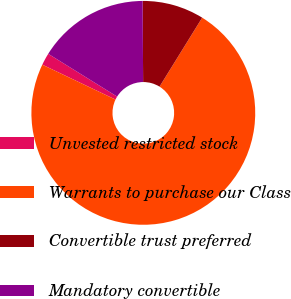Convert chart to OTSL. <chart><loc_0><loc_0><loc_500><loc_500><pie_chart><fcel>Unvested restricted stock<fcel>Warrants to purchase our Class<fcel>Convertible trust preferred<fcel>Mandatory convertible<nl><fcel>1.76%<fcel>73.26%<fcel>8.91%<fcel>16.06%<nl></chart> 